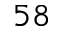<formula> <loc_0><loc_0><loc_500><loc_500>5 8</formula> 